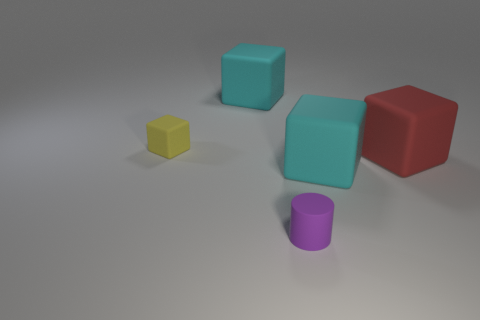Add 3 cyan matte objects. How many objects exist? 8 Subtract all cylinders. How many objects are left? 4 Subtract 0 gray spheres. How many objects are left? 5 Subtract all small blue blocks. Subtract all purple matte things. How many objects are left? 4 Add 5 big cubes. How many big cubes are left? 8 Add 5 tiny yellow metal objects. How many tiny yellow metal objects exist? 5 